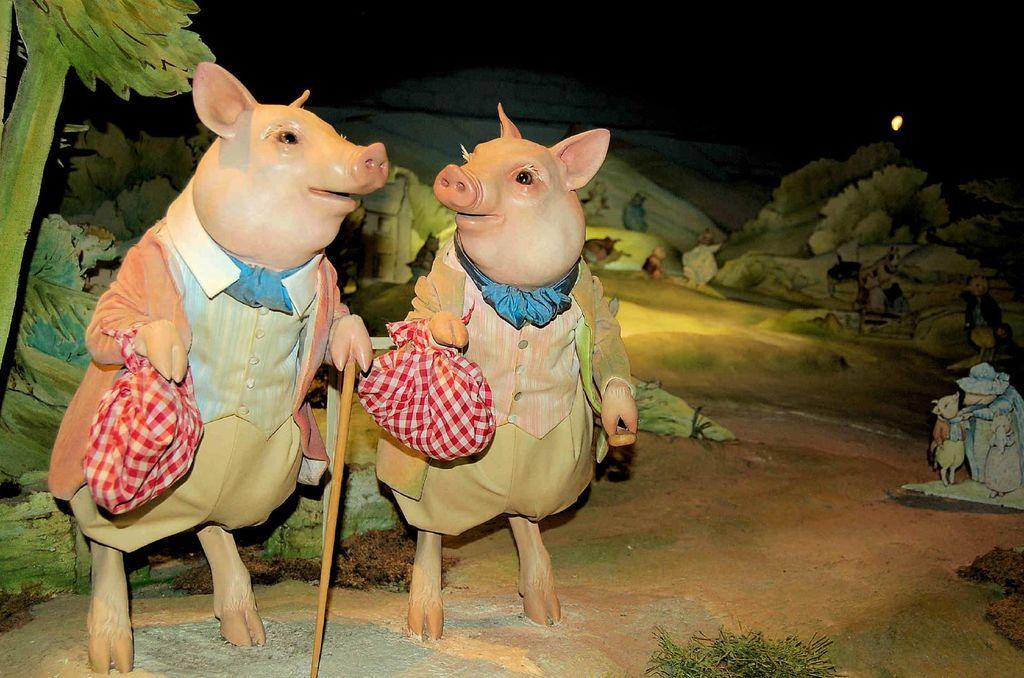What type of toys are on the left side of the image? There are two toy pigs on the left side of the image. What other toys can be seen in the background of the image? There are toy trees in the background area of the image. What is the weather like in the image? The provided facts do not mention any information about the weather, so it cannot be determined from the image. 